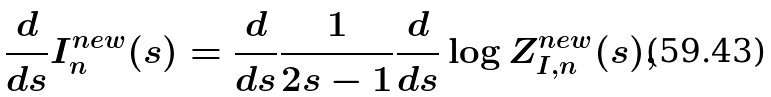Convert formula to latex. <formula><loc_0><loc_0><loc_500><loc_500>\frac { d } { d s } I ^ { n e w } _ { n } ( s ) = \frac { d } { d s } \frac { 1 } { 2 s - 1 } \frac { d } { d s } \log Z _ { I , n } ^ { n e w } ( s ) ,</formula> 